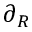<formula> <loc_0><loc_0><loc_500><loc_500>\partial _ { R }</formula> 